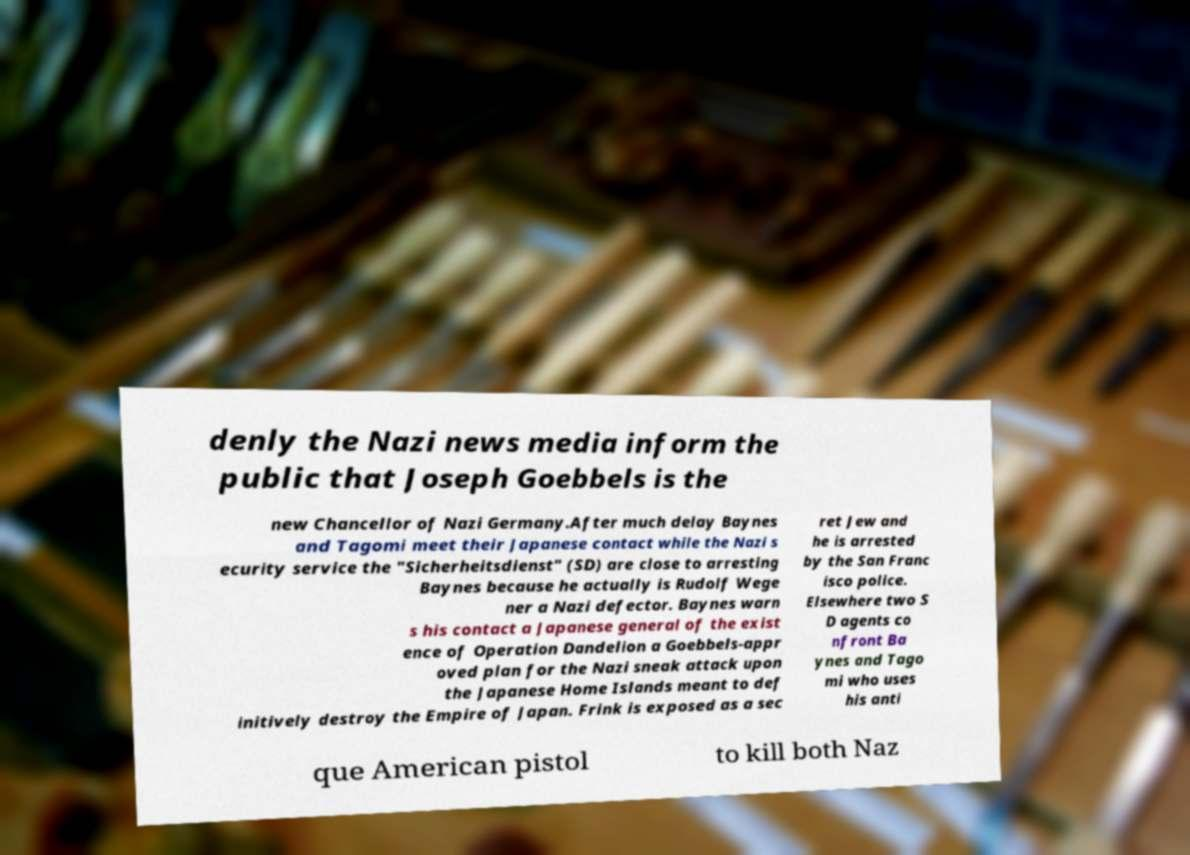Can you read and provide the text displayed in the image?This photo seems to have some interesting text. Can you extract and type it out for me? denly the Nazi news media inform the public that Joseph Goebbels is the new Chancellor of Nazi Germany.After much delay Baynes and Tagomi meet their Japanese contact while the Nazi s ecurity service the "Sicherheitsdienst" (SD) are close to arresting Baynes because he actually is Rudolf Wege ner a Nazi defector. Baynes warn s his contact a Japanese general of the exist ence of Operation Dandelion a Goebbels-appr oved plan for the Nazi sneak attack upon the Japanese Home Islands meant to def initively destroy the Empire of Japan. Frink is exposed as a sec ret Jew and he is arrested by the San Franc isco police. Elsewhere two S D agents co nfront Ba ynes and Tago mi who uses his anti que American pistol to kill both Naz 